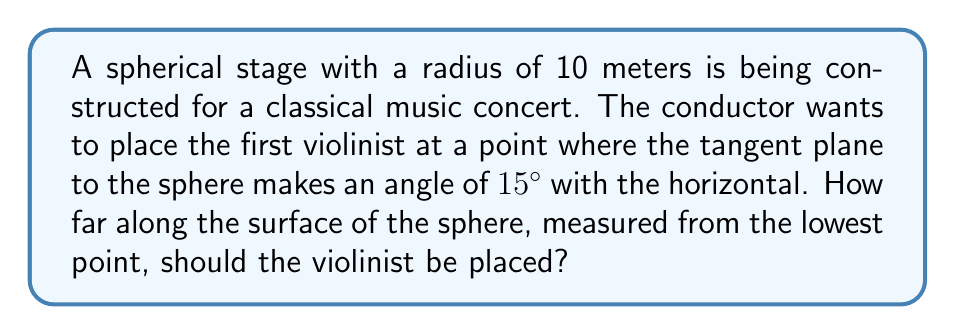Solve this math problem. Let's approach this step-by-step:

1) In spherical geometry, the angle between the tangent plane and the horizontal is equal to the central angle between the radius to that point and the vertical radius to the lowest point of the sphere.

2) Let $\theta$ be the central angle we're looking for. We're given that this angle is 15°.

3) The distance along the surface of a sphere is given by the arc length formula:
   
   $s = r\theta$

   Where $s$ is the arc length, $r$ is the radius, and $\theta$ is the central angle in radians.

4) We need to convert 15° to radians:
   
   $\theta = 15° \times \frac{\pi}{180°} = \frac{\pi}{12}$ radians

5) Now we can substitute into the arc length formula:

   $s = 10 \times \frac{\pi}{12} = \frac{5\pi}{6}$ meters

6) Therefore, the violinist should be placed $\frac{5\pi}{6}$ meters along the surface of the sphere, measured from the lowest point.

[asy]
import geometry;

size(200);
pair O = (0,0);
real r = 5;
draw(Circle(O,r));
pair A = (0,-r);
pair B = r*dir(75);
draw(O--A,dashed);
draw(O--B);
draw(A--B,blue);
label("O",O,NW);
label("A",A,S);
label("B",B,NE);
label("15°",O,NE);
draw(arc(O,A,B),red);
label("$\frac{5\pi}{6}$",arc(O,A,B),SE,red);
[/asy]
Answer: $\frac{5\pi}{6}$ meters 